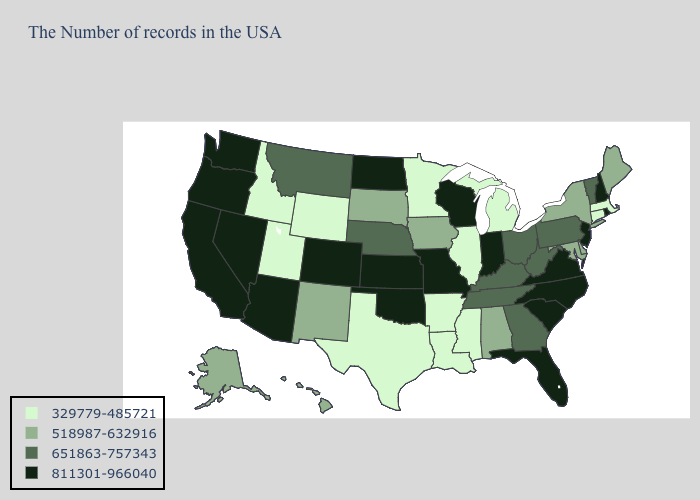What is the value of North Carolina?
Concise answer only. 811301-966040. Name the states that have a value in the range 811301-966040?
Be succinct. Rhode Island, New Hampshire, New Jersey, Virginia, North Carolina, South Carolina, Florida, Indiana, Wisconsin, Missouri, Kansas, Oklahoma, North Dakota, Colorado, Arizona, Nevada, California, Washington, Oregon. What is the value of Minnesota?
Be succinct. 329779-485721. Which states have the lowest value in the USA?
Answer briefly. Massachusetts, Connecticut, Michigan, Illinois, Mississippi, Louisiana, Arkansas, Minnesota, Texas, Wyoming, Utah, Idaho. Name the states that have a value in the range 651863-757343?
Be succinct. Vermont, Pennsylvania, West Virginia, Ohio, Georgia, Kentucky, Tennessee, Nebraska, Montana. What is the value of Arizona?
Keep it brief. 811301-966040. What is the highest value in states that border Utah?
Answer briefly. 811301-966040. Does Delaware have a higher value than Alabama?
Write a very short answer. No. Does Montana have a higher value than Iowa?
Quick response, please. Yes. Does Missouri have the highest value in the USA?
Short answer required. Yes. Does Alaska have the highest value in the West?
Quick response, please. No. Name the states that have a value in the range 329779-485721?
Answer briefly. Massachusetts, Connecticut, Michigan, Illinois, Mississippi, Louisiana, Arkansas, Minnesota, Texas, Wyoming, Utah, Idaho. What is the highest value in states that border Minnesota?
Be succinct. 811301-966040. What is the value of New York?
Short answer required. 518987-632916. 